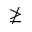Convert formula to latex. <formula><loc_0><loc_0><loc_500><loc_500>\ngeq</formula> 